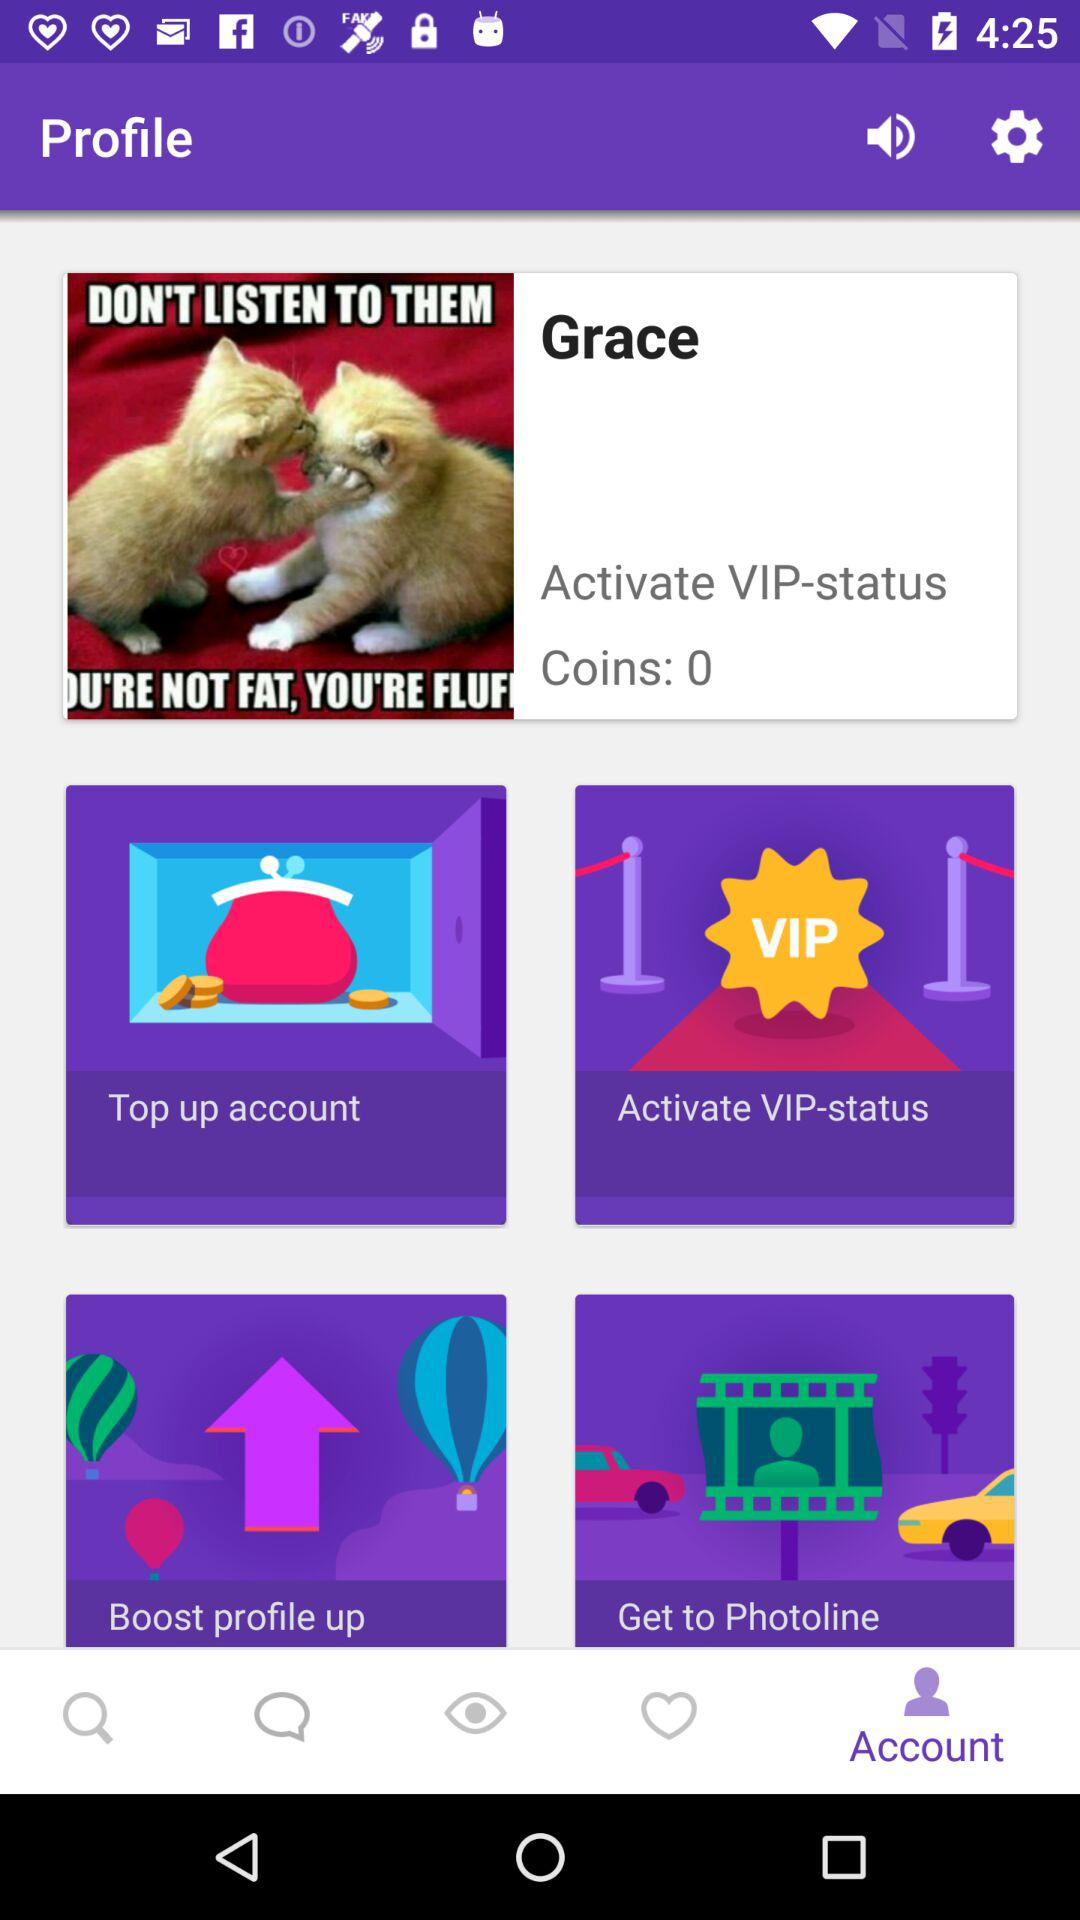How many coins are earned? The number of coins earned is 0. 